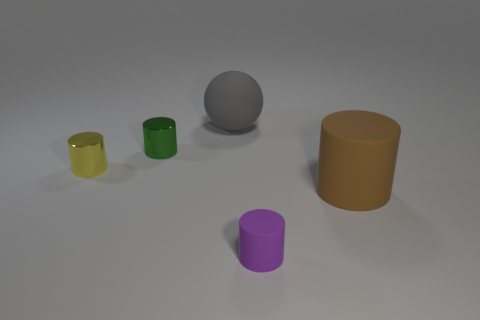Subtract 1 cylinders. How many cylinders are left? 3 Subtract all gray cylinders. Subtract all red cubes. How many cylinders are left? 4 Add 3 small green metal cubes. How many objects exist? 8 Subtract all cylinders. How many objects are left? 1 Add 1 large brown rubber objects. How many large brown rubber objects exist? 2 Subtract 0 red spheres. How many objects are left? 5 Subtract all gray rubber spheres. Subtract all small green metallic cylinders. How many objects are left? 3 Add 2 large gray rubber balls. How many large gray rubber balls are left? 3 